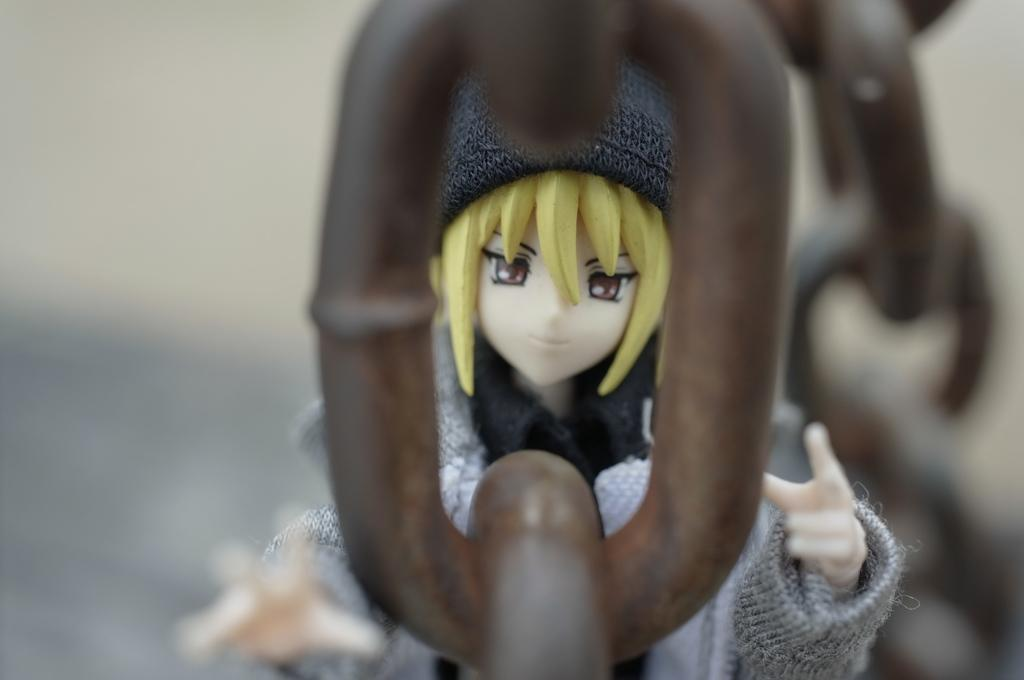What type of toy is in the image? There is a Barbie toy in the image. What is the Barbie toy wearing? The Barbie toy has clothes. What can be seen in the foreground of the image? There is a metal chain in the foreground of the image. How would you describe the background of the image? The background of the image is blurred. What type of decision can be seen being made by the Barbie toy in the image? There is no decision-making process depicted in the image; it simply shows a Barbie toy with clothes. What type of underwear is the Barbie toy wearing in the image? The provided facts do not mention any underwear, so we cannot determine what type the Barbie toy might be wearing. 